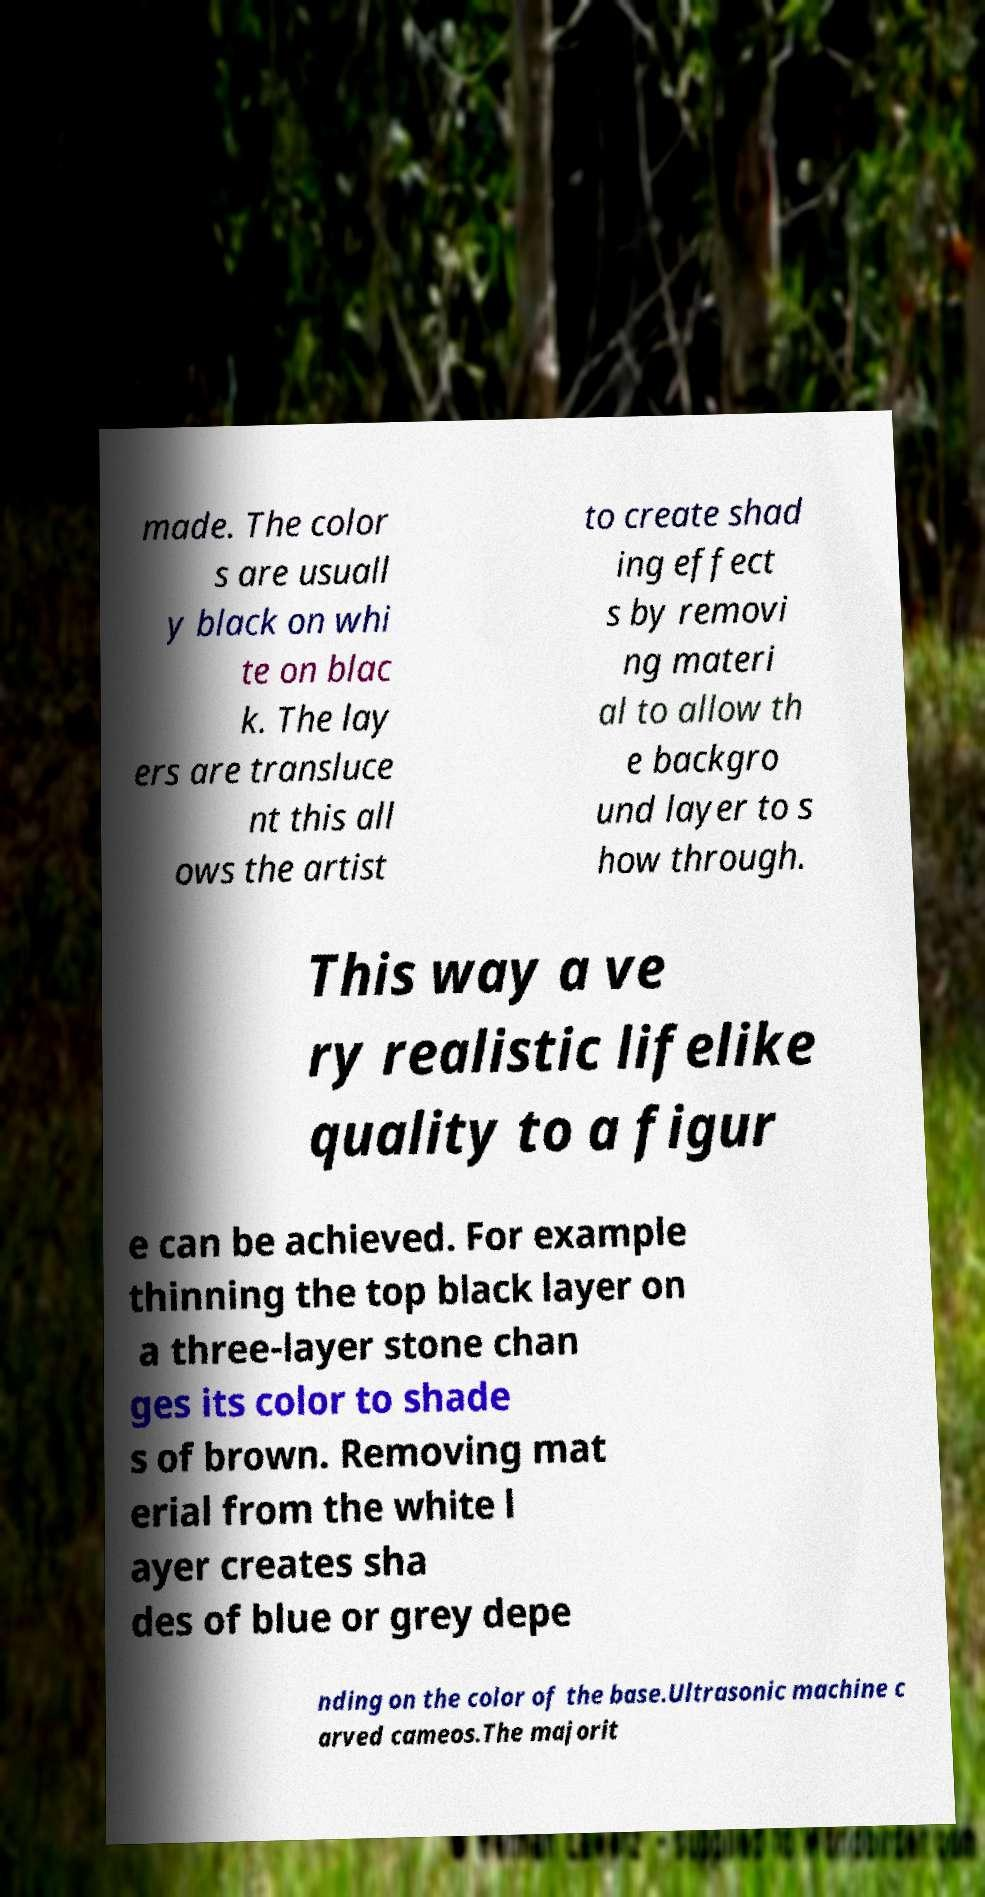Can you accurately transcribe the text from the provided image for me? made. The color s are usuall y black on whi te on blac k. The lay ers are transluce nt this all ows the artist to create shad ing effect s by removi ng materi al to allow th e backgro und layer to s how through. This way a ve ry realistic lifelike quality to a figur e can be achieved. For example thinning the top black layer on a three-layer stone chan ges its color to shade s of brown. Removing mat erial from the white l ayer creates sha des of blue or grey depe nding on the color of the base.Ultrasonic machine c arved cameos.The majorit 